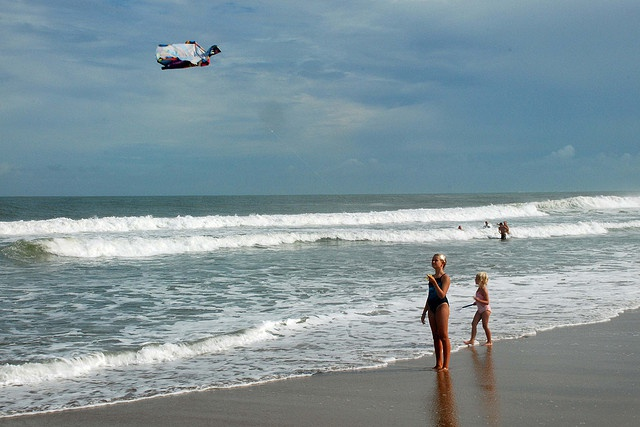Describe the objects in this image and their specific colors. I can see people in gray, black, maroon, and brown tones, kite in gray, black, darkgray, and lightgray tones, people in gray, maroon, black, and brown tones, people in gray, black, maroon, and ivory tones, and people in gray, maroon, and brown tones in this image. 